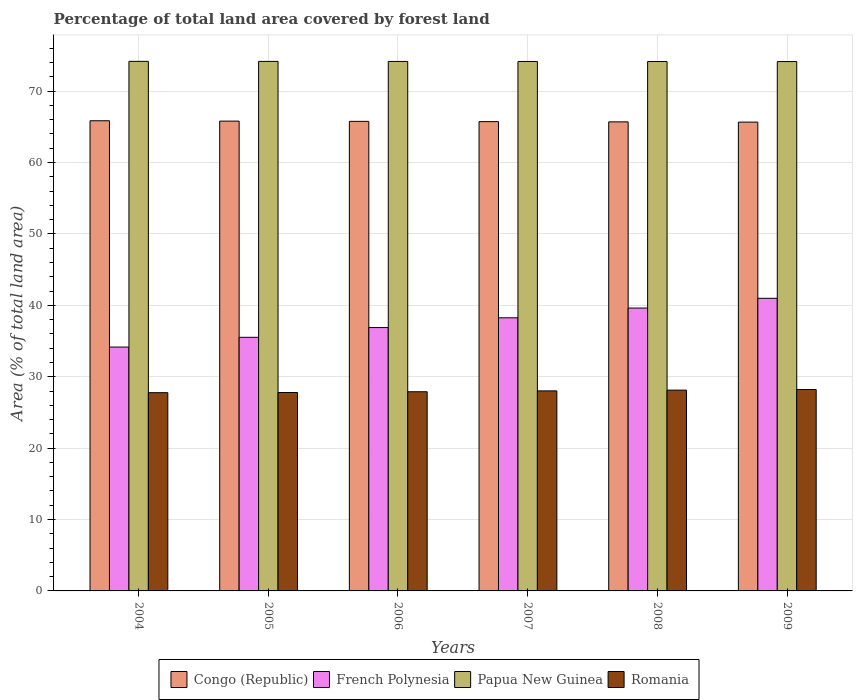How many groups of bars are there?
Make the answer very short. 6. Are the number of bars on each tick of the X-axis equal?
Ensure brevity in your answer.  Yes. How many bars are there on the 4th tick from the left?
Provide a short and direct response. 4. What is the label of the 5th group of bars from the left?
Ensure brevity in your answer.  2008. What is the percentage of forest land in Congo (Republic) in 2005?
Offer a very short reply. 65.8. Across all years, what is the maximum percentage of forest land in Papua New Guinea?
Offer a terse response. 74.17. Across all years, what is the minimum percentage of forest land in Congo (Republic)?
Provide a succinct answer. 65.66. In which year was the percentage of forest land in French Polynesia maximum?
Provide a short and direct response. 2009. What is the total percentage of forest land in Congo (Republic) in the graph?
Offer a very short reply. 394.5. What is the difference between the percentage of forest land in Papua New Guinea in 2005 and that in 2008?
Provide a succinct answer. 0.02. What is the difference between the percentage of forest land in Papua New Guinea in 2008 and the percentage of forest land in Romania in 2005?
Keep it short and to the point. 46.36. What is the average percentage of forest land in Papua New Guinea per year?
Offer a terse response. 74.16. In the year 2007, what is the difference between the percentage of forest land in French Polynesia and percentage of forest land in Congo (Republic)?
Provide a short and direct response. -27.48. In how many years, is the percentage of forest land in Romania greater than 34 %?
Provide a short and direct response. 0. What is the ratio of the percentage of forest land in French Polynesia in 2004 to that in 2008?
Offer a terse response. 0.86. Is the percentage of forest land in Romania in 2004 less than that in 2006?
Offer a very short reply. Yes. Is the difference between the percentage of forest land in French Polynesia in 2004 and 2005 greater than the difference between the percentage of forest land in Congo (Republic) in 2004 and 2005?
Ensure brevity in your answer.  No. What is the difference between the highest and the second highest percentage of forest land in French Polynesia?
Your answer should be compact. 1.37. What is the difference between the highest and the lowest percentage of forest land in Papua New Guinea?
Your answer should be very brief. 0.03. What does the 4th bar from the left in 2004 represents?
Offer a very short reply. Romania. What does the 4th bar from the right in 2004 represents?
Offer a very short reply. Congo (Republic). How many years are there in the graph?
Provide a succinct answer. 6. What is the difference between two consecutive major ticks on the Y-axis?
Your response must be concise. 10. Does the graph contain grids?
Keep it short and to the point. Yes. What is the title of the graph?
Your answer should be compact. Percentage of total land area covered by forest land. Does "Armenia" appear as one of the legend labels in the graph?
Make the answer very short. No. What is the label or title of the X-axis?
Give a very brief answer. Years. What is the label or title of the Y-axis?
Make the answer very short. Area (% of total land area). What is the Area (% of total land area) in Congo (Republic) in 2004?
Ensure brevity in your answer.  65.85. What is the Area (% of total land area) in French Polynesia in 2004?
Your answer should be compact. 34.15. What is the Area (% of total land area) in Papua New Guinea in 2004?
Your response must be concise. 74.17. What is the Area (% of total land area) of Romania in 2004?
Offer a terse response. 27.77. What is the Area (% of total land area) of Congo (Republic) in 2005?
Your answer should be very brief. 65.8. What is the Area (% of total land area) in French Polynesia in 2005?
Provide a short and direct response. 35.52. What is the Area (% of total land area) of Papua New Guinea in 2005?
Your answer should be compact. 74.16. What is the Area (% of total land area) of Romania in 2005?
Make the answer very short. 27.79. What is the Area (% of total land area) of Congo (Republic) in 2006?
Give a very brief answer. 65.77. What is the Area (% of total land area) of French Polynesia in 2006?
Offer a very short reply. 36.89. What is the Area (% of total land area) in Papua New Guinea in 2006?
Your answer should be very brief. 74.16. What is the Area (% of total land area) in Romania in 2006?
Your answer should be very brief. 27.9. What is the Area (% of total land area) in Congo (Republic) in 2007?
Ensure brevity in your answer.  65.73. What is the Area (% of total land area) of French Polynesia in 2007?
Provide a short and direct response. 38.25. What is the Area (% of total land area) of Papua New Guinea in 2007?
Offer a very short reply. 74.15. What is the Area (% of total land area) of Romania in 2007?
Your response must be concise. 28.02. What is the Area (% of total land area) of Congo (Republic) in 2008?
Your response must be concise. 65.7. What is the Area (% of total land area) of French Polynesia in 2008?
Your answer should be compact. 39.62. What is the Area (% of total land area) of Papua New Guinea in 2008?
Give a very brief answer. 74.15. What is the Area (% of total land area) of Romania in 2008?
Make the answer very short. 28.12. What is the Area (% of total land area) of Congo (Republic) in 2009?
Give a very brief answer. 65.66. What is the Area (% of total land area) in French Polynesia in 2009?
Provide a short and direct response. 40.98. What is the Area (% of total land area) of Papua New Guinea in 2009?
Provide a succinct answer. 74.14. What is the Area (% of total land area) in Romania in 2009?
Offer a terse response. 28.21. Across all years, what is the maximum Area (% of total land area) of Congo (Republic)?
Offer a very short reply. 65.85. Across all years, what is the maximum Area (% of total land area) of French Polynesia?
Ensure brevity in your answer.  40.98. Across all years, what is the maximum Area (% of total land area) of Papua New Guinea?
Your answer should be compact. 74.17. Across all years, what is the maximum Area (% of total land area) of Romania?
Provide a short and direct response. 28.21. Across all years, what is the minimum Area (% of total land area) of Congo (Republic)?
Offer a very short reply. 65.66. Across all years, what is the minimum Area (% of total land area) of French Polynesia?
Offer a terse response. 34.15. Across all years, what is the minimum Area (% of total land area) of Papua New Guinea?
Your answer should be very brief. 74.14. Across all years, what is the minimum Area (% of total land area) in Romania?
Your answer should be compact. 27.77. What is the total Area (% of total land area) of Congo (Republic) in the graph?
Provide a succinct answer. 394.5. What is the total Area (% of total land area) of French Polynesia in the graph?
Offer a very short reply. 225.41. What is the total Area (% of total land area) in Papua New Guinea in the graph?
Make the answer very short. 444.93. What is the total Area (% of total land area) of Romania in the graph?
Provide a succinct answer. 167.8. What is the difference between the Area (% of total land area) of Congo (Republic) in 2004 and that in 2005?
Your answer should be very brief. 0.05. What is the difference between the Area (% of total land area) of French Polynesia in 2004 and that in 2005?
Your answer should be very brief. -1.37. What is the difference between the Area (% of total land area) in Papua New Guinea in 2004 and that in 2005?
Your answer should be very brief. 0.01. What is the difference between the Area (% of total land area) in Romania in 2004 and that in 2005?
Your answer should be very brief. -0.02. What is the difference between the Area (% of total land area) in Congo (Republic) in 2004 and that in 2006?
Your answer should be very brief. 0.08. What is the difference between the Area (% of total land area) in French Polynesia in 2004 and that in 2006?
Your response must be concise. -2.73. What is the difference between the Area (% of total land area) in Papua New Guinea in 2004 and that in 2006?
Ensure brevity in your answer.  0.01. What is the difference between the Area (% of total land area) of Romania in 2004 and that in 2006?
Make the answer very short. -0.13. What is the difference between the Area (% of total land area) of Congo (Republic) in 2004 and that in 2007?
Your answer should be very brief. 0.12. What is the difference between the Area (% of total land area) of French Polynesia in 2004 and that in 2007?
Make the answer very short. -4.1. What is the difference between the Area (% of total land area) of Papua New Guinea in 2004 and that in 2007?
Offer a very short reply. 0.02. What is the difference between the Area (% of total land area) of Romania in 2004 and that in 2007?
Provide a short and direct response. -0.25. What is the difference between the Area (% of total land area) of Congo (Republic) in 2004 and that in 2008?
Give a very brief answer. 0.16. What is the difference between the Area (% of total land area) of French Polynesia in 2004 and that in 2008?
Offer a very short reply. -5.46. What is the difference between the Area (% of total land area) in Papua New Guinea in 2004 and that in 2008?
Make the answer very short. 0.02. What is the difference between the Area (% of total land area) of Romania in 2004 and that in 2008?
Offer a terse response. -0.36. What is the difference between the Area (% of total land area) in Congo (Republic) in 2004 and that in 2009?
Provide a succinct answer. 0.19. What is the difference between the Area (% of total land area) in French Polynesia in 2004 and that in 2009?
Offer a terse response. -6.83. What is the difference between the Area (% of total land area) of Papua New Guinea in 2004 and that in 2009?
Make the answer very short. 0.03. What is the difference between the Area (% of total land area) of Romania in 2004 and that in 2009?
Your response must be concise. -0.45. What is the difference between the Area (% of total land area) in Congo (Republic) in 2005 and that in 2006?
Your answer should be compact. 0.04. What is the difference between the Area (% of total land area) in French Polynesia in 2005 and that in 2006?
Your answer should be compact. -1.37. What is the difference between the Area (% of total land area) of Papua New Guinea in 2005 and that in 2006?
Offer a terse response. 0.01. What is the difference between the Area (% of total land area) of Romania in 2005 and that in 2006?
Offer a terse response. -0.11. What is the difference between the Area (% of total land area) in Congo (Republic) in 2005 and that in 2007?
Your answer should be compact. 0.07. What is the difference between the Area (% of total land area) of French Polynesia in 2005 and that in 2007?
Provide a short and direct response. -2.73. What is the difference between the Area (% of total land area) in Papua New Guinea in 2005 and that in 2007?
Keep it short and to the point. 0.01. What is the difference between the Area (% of total land area) of Romania in 2005 and that in 2007?
Give a very brief answer. -0.23. What is the difference between the Area (% of total land area) in Congo (Republic) in 2005 and that in 2008?
Provide a short and direct response. 0.11. What is the difference between the Area (% of total land area) of French Polynesia in 2005 and that in 2008?
Keep it short and to the point. -4.1. What is the difference between the Area (% of total land area) in Papua New Guinea in 2005 and that in 2008?
Give a very brief answer. 0.02. What is the difference between the Area (% of total land area) in Congo (Republic) in 2005 and that in 2009?
Offer a very short reply. 0.14. What is the difference between the Area (% of total land area) in French Polynesia in 2005 and that in 2009?
Make the answer very short. -5.46. What is the difference between the Area (% of total land area) in Papua New Guinea in 2005 and that in 2009?
Provide a short and direct response. 0.02. What is the difference between the Area (% of total land area) of Romania in 2005 and that in 2009?
Provide a short and direct response. -0.42. What is the difference between the Area (% of total land area) in Congo (Republic) in 2006 and that in 2007?
Your answer should be compact. 0.04. What is the difference between the Area (% of total land area) in French Polynesia in 2006 and that in 2007?
Make the answer very short. -1.37. What is the difference between the Area (% of total land area) in Papua New Guinea in 2006 and that in 2007?
Provide a succinct answer. 0.01. What is the difference between the Area (% of total land area) of Romania in 2006 and that in 2007?
Your response must be concise. -0.12. What is the difference between the Area (% of total land area) in Congo (Republic) in 2006 and that in 2008?
Ensure brevity in your answer.  0.07. What is the difference between the Area (% of total land area) in French Polynesia in 2006 and that in 2008?
Keep it short and to the point. -2.73. What is the difference between the Area (% of total land area) in Papua New Guinea in 2006 and that in 2008?
Provide a short and direct response. 0.01. What is the difference between the Area (% of total land area) in Romania in 2006 and that in 2008?
Offer a terse response. -0.23. What is the difference between the Area (% of total land area) of Congo (Republic) in 2006 and that in 2009?
Your response must be concise. 0.11. What is the difference between the Area (% of total land area) of French Polynesia in 2006 and that in 2009?
Offer a terse response. -4.1. What is the difference between the Area (% of total land area) of Papua New Guinea in 2006 and that in 2009?
Your answer should be compact. 0.02. What is the difference between the Area (% of total land area) in Romania in 2006 and that in 2009?
Your response must be concise. -0.31. What is the difference between the Area (% of total land area) in Congo (Republic) in 2007 and that in 2008?
Give a very brief answer. 0.04. What is the difference between the Area (% of total land area) in French Polynesia in 2007 and that in 2008?
Provide a succinct answer. -1.37. What is the difference between the Area (% of total land area) in Papua New Guinea in 2007 and that in 2008?
Offer a very short reply. 0.01. What is the difference between the Area (% of total land area) in Romania in 2007 and that in 2008?
Make the answer very short. -0.11. What is the difference between the Area (% of total land area) of Congo (Republic) in 2007 and that in 2009?
Your response must be concise. 0.07. What is the difference between the Area (% of total land area) in French Polynesia in 2007 and that in 2009?
Your response must be concise. -2.73. What is the difference between the Area (% of total land area) of Papua New Guinea in 2007 and that in 2009?
Your response must be concise. 0.01. What is the difference between the Area (% of total land area) of Romania in 2007 and that in 2009?
Your answer should be very brief. -0.19. What is the difference between the Area (% of total land area) in Congo (Republic) in 2008 and that in 2009?
Offer a terse response. 0.04. What is the difference between the Area (% of total land area) of French Polynesia in 2008 and that in 2009?
Offer a terse response. -1.37. What is the difference between the Area (% of total land area) of Papua New Guinea in 2008 and that in 2009?
Your answer should be very brief. 0.01. What is the difference between the Area (% of total land area) in Romania in 2008 and that in 2009?
Make the answer very short. -0.09. What is the difference between the Area (% of total land area) of Congo (Republic) in 2004 and the Area (% of total land area) of French Polynesia in 2005?
Provide a succinct answer. 30.33. What is the difference between the Area (% of total land area) in Congo (Republic) in 2004 and the Area (% of total land area) in Papua New Guinea in 2005?
Give a very brief answer. -8.31. What is the difference between the Area (% of total land area) in Congo (Republic) in 2004 and the Area (% of total land area) in Romania in 2005?
Your answer should be compact. 38.06. What is the difference between the Area (% of total land area) of French Polynesia in 2004 and the Area (% of total land area) of Papua New Guinea in 2005?
Your answer should be very brief. -40.01. What is the difference between the Area (% of total land area) in French Polynesia in 2004 and the Area (% of total land area) in Romania in 2005?
Provide a short and direct response. 6.36. What is the difference between the Area (% of total land area) in Papua New Guinea in 2004 and the Area (% of total land area) in Romania in 2005?
Make the answer very short. 46.38. What is the difference between the Area (% of total land area) of Congo (Republic) in 2004 and the Area (% of total land area) of French Polynesia in 2006?
Give a very brief answer. 28.97. What is the difference between the Area (% of total land area) of Congo (Republic) in 2004 and the Area (% of total land area) of Papua New Guinea in 2006?
Make the answer very short. -8.31. What is the difference between the Area (% of total land area) of Congo (Republic) in 2004 and the Area (% of total land area) of Romania in 2006?
Your response must be concise. 37.95. What is the difference between the Area (% of total land area) in French Polynesia in 2004 and the Area (% of total land area) in Papua New Guinea in 2006?
Your answer should be very brief. -40.01. What is the difference between the Area (% of total land area) in French Polynesia in 2004 and the Area (% of total land area) in Romania in 2006?
Your answer should be very brief. 6.26. What is the difference between the Area (% of total land area) of Papua New Guinea in 2004 and the Area (% of total land area) of Romania in 2006?
Give a very brief answer. 46.27. What is the difference between the Area (% of total land area) of Congo (Republic) in 2004 and the Area (% of total land area) of French Polynesia in 2007?
Your answer should be very brief. 27.6. What is the difference between the Area (% of total land area) in Congo (Republic) in 2004 and the Area (% of total land area) in Papua New Guinea in 2007?
Offer a very short reply. -8.3. What is the difference between the Area (% of total land area) in Congo (Republic) in 2004 and the Area (% of total land area) in Romania in 2007?
Keep it short and to the point. 37.83. What is the difference between the Area (% of total land area) of French Polynesia in 2004 and the Area (% of total land area) of Papua New Guinea in 2007?
Your answer should be very brief. -40. What is the difference between the Area (% of total land area) in French Polynesia in 2004 and the Area (% of total land area) in Romania in 2007?
Ensure brevity in your answer.  6.14. What is the difference between the Area (% of total land area) of Papua New Guinea in 2004 and the Area (% of total land area) of Romania in 2007?
Your answer should be very brief. 46.15. What is the difference between the Area (% of total land area) of Congo (Republic) in 2004 and the Area (% of total land area) of French Polynesia in 2008?
Provide a succinct answer. 26.23. What is the difference between the Area (% of total land area) in Congo (Republic) in 2004 and the Area (% of total land area) in Papua New Guinea in 2008?
Ensure brevity in your answer.  -8.3. What is the difference between the Area (% of total land area) of Congo (Republic) in 2004 and the Area (% of total land area) of Romania in 2008?
Keep it short and to the point. 37.73. What is the difference between the Area (% of total land area) of French Polynesia in 2004 and the Area (% of total land area) of Papua New Guinea in 2008?
Your answer should be compact. -39.99. What is the difference between the Area (% of total land area) of French Polynesia in 2004 and the Area (% of total land area) of Romania in 2008?
Your answer should be compact. 6.03. What is the difference between the Area (% of total land area) of Papua New Guinea in 2004 and the Area (% of total land area) of Romania in 2008?
Make the answer very short. 46.05. What is the difference between the Area (% of total land area) in Congo (Republic) in 2004 and the Area (% of total land area) in French Polynesia in 2009?
Ensure brevity in your answer.  24.87. What is the difference between the Area (% of total land area) in Congo (Republic) in 2004 and the Area (% of total land area) in Papua New Guinea in 2009?
Give a very brief answer. -8.29. What is the difference between the Area (% of total land area) in Congo (Republic) in 2004 and the Area (% of total land area) in Romania in 2009?
Provide a succinct answer. 37.64. What is the difference between the Area (% of total land area) in French Polynesia in 2004 and the Area (% of total land area) in Papua New Guinea in 2009?
Offer a very short reply. -39.99. What is the difference between the Area (% of total land area) in French Polynesia in 2004 and the Area (% of total land area) in Romania in 2009?
Your answer should be very brief. 5.94. What is the difference between the Area (% of total land area) in Papua New Guinea in 2004 and the Area (% of total land area) in Romania in 2009?
Provide a short and direct response. 45.96. What is the difference between the Area (% of total land area) of Congo (Republic) in 2005 and the Area (% of total land area) of French Polynesia in 2006?
Provide a succinct answer. 28.92. What is the difference between the Area (% of total land area) of Congo (Republic) in 2005 and the Area (% of total land area) of Papua New Guinea in 2006?
Ensure brevity in your answer.  -8.36. What is the difference between the Area (% of total land area) in Congo (Republic) in 2005 and the Area (% of total land area) in Romania in 2006?
Offer a very short reply. 37.9. What is the difference between the Area (% of total land area) of French Polynesia in 2005 and the Area (% of total land area) of Papua New Guinea in 2006?
Your answer should be very brief. -38.64. What is the difference between the Area (% of total land area) in French Polynesia in 2005 and the Area (% of total land area) in Romania in 2006?
Your answer should be compact. 7.62. What is the difference between the Area (% of total land area) in Papua New Guinea in 2005 and the Area (% of total land area) in Romania in 2006?
Give a very brief answer. 46.27. What is the difference between the Area (% of total land area) of Congo (Republic) in 2005 and the Area (% of total land area) of French Polynesia in 2007?
Your response must be concise. 27.55. What is the difference between the Area (% of total land area) of Congo (Republic) in 2005 and the Area (% of total land area) of Papua New Guinea in 2007?
Your answer should be very brief. -8.35. What is the difference between the Area (% of total land area) of Congo (Republic) in 2005 and the Area (% of total land area) of Romania in 2007?
Provide a succinct answer. 37.78. What is the difference between the Area (% of total land area) of French Polynesia in 2005 and the Area (% of total land area) of Papua New Guinea in 2007?
Your answer should be very brief. -38.63. What is the difference between the Area (% of total land area) of French Polynesia in 2005 and the Area (% of total land area) of Romania in 2007?
Provide a succinct answer. 7.5. What is the difference between the Area (% of total land area) of Papua New Guinea in 2005 and the Area (% of total land area) of Romania in 2007?
Make the answer very short. 46.15. What is the difference between the Area (% of total land area) in Congo (Republic) in 2005 and the Area (% of total land area) in French Polynesia in 2008?
Offer a very short reply. 26.18. What is the difference between the Area (% of total land area) in Congo (Republic) in 2005 and the Area (% of total land area) in Papua New Guinea in 2008?
Make the answer very short. -8.35. What is the difference between the Area (% of total land area) of Congo (Republic) in 2005 and the Area (% of total land area) of Romania in 2008?
Provide a succinct answer. 37.68. What is the difference between the Area (% of total land area) in French Polynesia in 2005 and the Area (% of total land area) in Papua New Guinea in 2008?
Your answer should be compact. -38.63. What is the difference between the Area (% of total land area) in French Polynesia in 2005 and the Area (% of total land area) in Romania in 2008?
Make the answer very short. 7.4. What is the difference between the Area (% of total land area) of Papua New Guinea in 2005 and the Area (% of total land area) of Romania in 2008?
Keep it short and to the point. 46.04. What is the difference between the Area (% of total land area) of Congo (Republic) in 2005 and the Area (% of total land area) of French Polynesia in 2009?
Provide a succinct answer. 24.82. What is the difference between the Area (% of total land area) of Congo (Republic) in 2005 and the Area (% of total land area) of Papua New Guinea in 2009?
Provide a succinct answer. -8.34. What is the difference between the Area (% of total land area) of Congo (Republic) in 2005 and the Area (% of total land area) of Romania in 2009?
Offer a terse response. 37.59. What is the difference between the Area (% of total land area) of French Polynesia in 2005 and the Area (% of total land area) of Papua New Guinea in 2009?
Your answer should be very brief. -38.62. What is the difference between the Area (% of total land area) of French Polynesia in 2005 and the Area (% of total land area) of Romania in 2009?
Your answer should be very brief. 7.31. What is the difference between the Area (% of total land area) in Papua New Guinea in 2005 and the Area (% of total land area) in Romania in 2009?
Offer a terse response. 45.95. What is the difference between the Area (% of total land area) in Congo (Republic) in 2006 and the Area (% of total land area) in French Polynesia in 2007?
Provide a short and direct response. 27.51. What is the difference between the Area (% of total land area) of Congo (Republic) in 2006 and the Area (% of total land area) of Papua New Guinea in 2007?
Your response must be concise. -8.39. What is the difference between the Area (% of total land area) in Congo (Republic) in 2006 and the Area (% of total land area) in Romania in 2007?
Provide a short and direct response. 37.75. What is the difference between the Area (% of total land area) of French Polynesia in 2006 and the Area (% of total land area) of Papua New Guinea in 2007?
Offer a very short reply. -37.27. What is the difference between the Area (% of total land area) in French Polynesia in 2006 and the Area (% of total land area) in Romania in 2007?
Your answer should be compact. 8.87. What is the difference between the Area (% of total land area) in Papua New Guinea in 2006 and the Area (% of total land area) in Romania in 2007?
Offer a terse response. 46.14. What is the difference between the Area (% of total land area) of Congo (Republic) in 2006 and the Area (% of total land area) of French Polynesia in 2008?
Provide a succinct answer. 26.15. What is the difference between the Area (% of total land area) in Congo (Republic) in 2006 and the Area (% of total land area) in Papua New Guinea in 2008?
Your answer should be very brief. -8.38. What is the difference between the Area (% of total land area) in Congo (Republic) in 2006 and the Area (% of total land area) in Romania in 2008?
Make the answer very short. 37.64. What is the difference between the Area (% of total land area) of French Polynesia in 2006 and the Area (% of total land area) of Papua New Guinea in 2008?
Offer a terse response. -37.26. What is the difference between the Area (% of total land area) of French Polynesia in 2006 and the Area (% of total land area) of Romania in 2008?
Give a very brief answer. 8.76. What is the difference between the Area (% of total land area) in Papua New Guinea in 2006 and the Area (% of total land area) in Romania in 2008?
Keep it short and to the point. 46.04. What is the difference between the Area (% of total land area) in Congo (Republic) in 2006 and the Area (% of total land area) in French Polynesia in 2009?
Your answer should be compact. 24.78. What is the difference between the Area (% of total land area) in Congo (Republic) in 2006 and the Area (% of total land area) in Papua New Guinea in 2009?
Ensure brevity in your answer.  -8.38. What is the difference between the Area (% of total land area) in Congo (Republic) in 2006 and the Area (% of total land area) in Romania in 2009?
Your answer should be compact. 37.55. What is the difference between the Area (% of total land area) in French Polynesia in 2006 and the Area (% of total land area) in Papua New Guinea in 2009?
Your answer should be very brief. -37.26. What is the difference between the Area (% of total land area) in French Polynesia in 2006 and the Area (% of total land area) in Romania in 2009?
Your answer should be very brief. 8.67. What is the difference between the Area (% of total land area) of Papua New Guinea in 2006 and the Area (% of total land area) of Romania in 2009?
Provide a succinct answer. 45.95. What is the difference between the Area (% of total land area) in Congo (Republic) in 2007 and the Area (% of total land area) in French Polynesia in 2008?
Provide a short and direct response. 26.11. What is the difference between the Area (% of total land area) in Congo (Republic) in 2007 and the Area (% of total land area) in Papua New Guinea in 2008?
Keep it short and to the point. -8.42. What is the difference between the Area (% of total land area) of Congo (Republic) in 2007 and the Area (% of total land area) of Romania in 2008?
Your answer should be compact. 37.61. What is the difference between the Area (% of total land area) of French Polynesia in 2007 and the Area (% of total land area) of Papua New Guinea in 2008?
Keep it short and to the point. -35.9. What is the difference between the Area (% of total land area) in French Polynesia in 2007 and the Area (% of total land area) in Romania in 2008?
Make the answer very short. 10.13. What is the difference between the Area (% of total land area) of Papua New Guinea in 2007 and the Area (% of total land area) of Romania in 2008?
Offer a terse response. 46.03. What is the difference between the Area (% of total land area) of Congo (Republic) in 2007 and the Area (% of total land area) of French Polynesia in 2009?
Offer a very short reply. 24.75. What is the difference between the Area (% of total land area) in Congo (Republic) in 2007 and the Area (% of total land area) in Papua New Guinea in 2009?
Ensure brevity in your answer.  -8.41. What is the difference between the Area (% of total land area) of Congo (Republic) in 2007 and the Area (% of total land area) of Romania in 2009?
Your response must be concise. 37.52. What is the difference between the Area (% of total land area) of French Polynesia in 2007 and the Area (% of total land area) of Papua New Guinea in 2009?
Offer a very short reply. -35.89. What is the difference between the Area (% of total land area) of French Polynesia in 2007 and the Area (% of total land area) of Romania in 2009?
Provide a succinct answer. 10.04. What is the difference between the Area (% of total land area) of Papua New Guinea in 2007 and the Area (% of total land area) of Romania in 2009?
Your answer should be compact. 45.94. What is the difference between the Area (% of total land area) of Congo (Republic) in 2008 and the Area (% of total land area) of French Polynesia in 2009?
Your response must be concise. 24.71. What is the difference between the Area (% of total land area) in Congo (Republic) in 2008 and the Area (% of total land area) in Papua New Guinea in 2009?
Your answer should be very brief. -8.45. What is the difference between the Area (% of total land area) of Congo (Republic) in 2008 and the Area (% of total land area) of Romania in 2009?
Offer a very short reply. 37.48. What is the difference between the Area (% of total land area) of French Polynesia in 2008 and the Area (% of total land area) of Papua New Guinea in 2009?
Give a very brief answer. -34.52. What is the difference between the Area (% of total land area) of French Polynesia in 2008 and the Area (% of total land area) of Romania in 2009?
Offer a very short reply. 11.41. What is the difference between the Area (% of total land area) in Papua New Guinea in 2008 and the Area (% of total land area) in Romania in 2009?
Make the answer very short. 45.94. What is the average Area (% of total land area) in Congo (Republic) per year?
Your response must be concise. 65.75. What is the average Area (% of total land area) of French Polynesia per year?
Offer a terse response. 37.57. What is the average Area (% of total land area) of Papua New Guinea per year?
Keep it short and to the point. 74.16. What is the average Area (% of total land area) in Romania per year?
Your response must be concise. 27.97. In the year 2004, what is the difference between the Area (% of total land area) of Congo (Republic) and Area (% of total land area) of French Polynesia?
Make the answer very short. 31.7. In the year 2004, what is the difference between the Area (% of total land area) in Congo (Republic) and Area (% of total land area) in Papua New Guinea?
Make the answer very short. -8.32. In the year 2004, what is the difference between the Area (% of total land area) of Congo (Republic) and Area (% of total land area) of Romania?
Offer a very short reply. 38.09. In the year 2004, what is the difference between the Area (% of total land area) in French Polynesia and Area (% of total land area) in Papua New Guinea?
Give a very brief answer. -40.02. In the year 2004, what is the difference between the Area (% of total land area) of French Polynesia and Area (% of total land area) of Romania?
Give a very brief answer. 6.39. In the year 2004, what is the difference between the Area (% of total land area) of Papua New Guinea and Area (% of total land area) of Romania?
Give a very brief answer. 46.41. In the year 2005, what is the difference between the Area (% of total land area) of Congo (Republic) and Area (% of total land area) of French Polynesia?
Ensure brevity in your answer.  30.28. In the year 2005, what is the difference between the Area (% of total land area) of Congo (Republic) and Area (% of total land area) of Papua New Guinea?
Your answer should be compact. -8.36. In the year 2005, what is the difference between the Area (% of total land area) of Congo (Republic) and Area (% of total land area) of Romania?
Keep it short and to the point. 38.01. In the year 2005, what is the difference between the Area (% of total land area) of French Polynesia and Area (% of total land area) of Papua New Guinea?
Ensure brevity in your answer.  -38.65. In the year 2005, what is the difference between the Area (% of total land area) in French Polynesia and Area (% of total land area) in Romania?
Your response must be concise. 7.73. In the year 2005, what is the difference between the Area (% of total land area) in Papua New Guinea and Area (% of total land area) in Romania?
Your response must be concise. 46.37. In the year 2006, what is the difference between the Area (% of total land area) in Congo (Republic) and Area (% of total land area) in French Polynesia?
Offer a terse response. 28.88. In the year 2006, what is the difference between the Area (% of total land area) of Congo (Republic) and Area (% of total land area) of Papua New Guinea?
Your answer should be very brief. -8.39. In the year 2006, what is the difference between the Area (% of total land area) in Congo (Republic) and Area (% of total land area) in Romania?
Ensure brevity in your answer.  37.87. In the year 2006, what is the difference between the Area (% of total land area) of French Polynesia and Area (% of total land area) of Papua New Guinea?
Your answer should be very brief. -37.27. In the year 2006, what is the difference between the Area (% of total land area) in French Polynesia and Area (% of total land area) in Romania?
Offer a very short reply. 8.99. In the year 2006, what is the difference between the Area (% of total land area) of Papua New Guinea and Area (% of total land area) of Romania?
Provide a succinct answer. 46.26. In the year 2007, what is the difference between the Area (% of total land area) of Congo (Republic) and Area (% of total land area) of French Polynesia?
Provide a short and direct response. 27.48. In the year 2007, what is the difference between the Area (% of total land area) in Congo (Republic) and Area (% of total land area) in Papua New Guinea?
Your answer should be compact. -8.42. In the year 2007, what is the difference between the Area (% of total land area) of Congo (Republic) and Area (% of total land area) of Romania?
Your answer should be very brief. 37.71. In the year 2007, what is the difference between the Area (% of total land area) in French Polynesia and Area (% of total land area) in Papua New Guinea?
Your answer should be compact. -35.9. In the year 2007, what is the difference between the Area (% of total land area) of French Polynesia and Area (% of total land area) of Romania?
Offer a terse response. 10.24. In the year 2007, what is the difference between the Area (% of total land area) of Papua New Guinea and Area (% of total land area) of Romania?
Your response must be concise. 46.14. In the year 2008, what is the difference between the Area (% of total land area) in Congo (Republic) and Area (% of total land area) in French Polynesia?
Ensure brevity in your answer.  26.08. In the year 2008, what is the difference between the Area (% of total land area) in Congo (Republic) and Area (% of total land area) in Papua New Guinea?
Offer a terse response. -8.45. In the year 2008, what is the difference between the Area (% of total land area) in Congo (Republic) and Area (% of total land area) in Romania?
Offer a very short reply. 37.57. In the year 2008, what is the difference between the Area (% of total land area) of French Polynesia and Area (% of total land area) of Papua New Guinea?
Offer a terse response. -34.53. In the year 2008, what is the difference between the Area (% of total land area) of French Polynesia and Area (% of total land area) of Romania?
Provide a short and direct response. 11.49. In the year 2008, what is the difference between the Area (% of total land area) in Papua New Guinea and Area (% of total land area) in Romania?
Give a very brief answer. 46.02. In the year 2009, what is the difference between the Area (% of total land area) in Congo (Republic) and Area (% of total land area) in French Polynesia?
Provide a short and direct response. 24.68. In the year 2009, what is the difference between the Area (% of total land area) of Congo (Republic) and Area (% of total land area) of Papua New Guinea?
Give a very brief answer. -8.48. In the year 2009, what is the difference between the Area (% of total land area) in Congo (Republic) and Area (% of total land area) in Romania?
Keep it short and to the point. 37.45. In the year 2009, what is the difference between the Area (% of total land area) of French Polynesia and Area (% of total land area) of Papua New Guinea?
Provide a succinct answer. -33.16. In the year 2009, what is the difference between the Area (% of total land area) of French Polynesia and Area (% of total land area) of Romania?
Your answer should be very brief. 12.77. In the year 2009, what is the difference between the Area (% of total land area) of Papua New Guinea and Area (% of total land area) of Romania?
Offer a terse response. 45.93. What is the ratio of the Area (% of total land area) of Congo (Republic) in 2004 to that in 2005?
Keep it short and to the point. 1. What is the ratio of the Area (% of total land area) of French Polynesia in 2004 to that in 2005?
Your response must be concise. 0.96. What is the ratio of the Area (% of total land area) in Romania in 2004 to that in 2005?
Keep it short and to the point. 1. What is the ratio of the Area (% of total land area) in Congo (Republic) in 2004 to that in 2006?
Your response must be concise. 1. What is the ratio of the Area (% of total land area) in French Polynesia in 2004 to that in 2006?
Give a very brief answer. 0.93. What is the ratio of the Area (% of total land area) of Papua New Guinea in 2004 to that in 2006?
Provide a short and direct response. 1. What is the ratio of the Area (% of total land area) in Romania in 2004 to that in 2006?
Your answer should be compact. 1. What is the ratio of the Area (% of total land area) in French Polynesia in 2004 to that in 2007?
Provide a succinct answer. 0.89. What is the ratio of the Area (% of total land area) of Papua New Guinea in 2004 to that in 2007?
Provide a succinct answer. 1. What is the ratio of the Area (% of total land area) of French Polynesia in 2004 to that in 2008?
Your answer should be compact. 0.86. What is the ratio of the Area (% of total land area) of Romania in 2004 to that in 2008?
Provide a succinct answer. 0.99. What is the ratio of the Area (% of total land area) of French Polynesia in 2004 to that in 2009?
Keep it short and to the point. 0.83. What is the ratio of the Area (% of total land area) in Papua New Guinea in 2004 to that in 2009?
Keep it short and to the point. 1. What is the ratio of the Area (% of total land area) in Romania in 2004 to that in 2009?
Give a very brief answer. 0.98. What is the ratio of the Area (% of total land area) in Congo (Republic) in 2005 to that in 2006?
Provide a succinct answer. 1. What is the ratio of the Area (% of total land area) in French Polynesia in 2005 to that in 2006?
Provide a short and direct response. 0.96. What is the ratio of the Area (% of total land area) in Papua New Guinea in 2005 to that in 2006?
Your answer should be compact. 1. What is the ratio of the Area (% of total land area) of French Polynesia in 2005 to that in 2007?
Make the answer very short. 0.93. What is the ratio of the Area (% of total land area) of Papua New Guinea in 2005 to that in 2007?
Offer a terse response. 1. What is the ratio of the Area (% of total land area) of Romania in 2005 to that in 2007?
Ensure brevity in your answer.  0.99. What is the ratio of the Area (% of total land area) in Congo (Republic) in 2005 to that in 2008?
Offer a very short reply. 1. What is the ratio of the Area (% of total land area) in French Polynesia in 2005 to that in 2008?
Give a very brief answer. 0.9. What is the ratio of the Area (% of total land area) of Papua New Guinea in 2005 to that in 2008?
Offer a very short reply. 1. What is the ratio of the Area (% of total land area) of Romania in 2005 to that in 2008?
Offer a very short reply. 0.99. What is the ratio of the Area (% of total land area) of French Polynesia in 2005 to that in 2009?
Give a very brief answer. 0.87. What is the ratio of the Area (% of total land area) in Romania in 2005 to that in 2009?
Keep it short and to the point. 0.99. What is the ratio of the Area (% of total land area) of Congo (Republic) in 2006 to that in 2008?
Make the answer very short. 1. What is the ratio of the Area (% of total land area) in Congo (Republic) in 2006 to that in 2009?
Make the answer very short. 1. What is the ratio of the Area (% of total land area) in Papua New Guinea in 2006 to that in 2009?
Make the answer very short. 1. What is the ratio of the Area (% of total land area) in Romania in 2006 to that in 2009?
Make the answer very short. 0.99. What is the ratio of the Area (% of total land area) in French Polynesia in 2007 to that in 2008?
Offer a terse response. 0.97. What is the ratio of the Area (% of total land area) in Papua New Guinea in 2007 to that in 2008?
Offer a terse response. 1. What is the ratio of the Area (% of total land area) of Congo (Republic) in 2007 to that in 2009?
Keep it short and to the point. 1. What is the ratio of the Area (% of total land area) of Romania in 2007 to that in 2009?
Offer a terse response. 0.99. What is the ratio of the Area (% of total land area) in Congo (Republic) in 2008 to that in 2009?
Provide a short and direct response. 1. What is the ratio of the Area (% of total land area) in French Polynesia in 2008 to that in 2009?
Your response must be concise. 0.97. What is the ratio of the Area (% of total land area) in Papua New Guinea in 2008 to that in 2009?
Provide a short and direct response. 1. What is the difference between the highest and the second highest Area (% of total land area) in Congo (Republic)?
Your response must be concise. 0.05. What is the difference between the highest and the second highest Area (% of total land area) of French Polynesia?
Keep it short and to the point. 1.37. What is the difference between the highest and the second highest Area (% of total land area) of Papua New Guinea?
Offer a terse response. 0.01. What is the difference between the highest and the second highest Area (% of total land area) in Romania?
Your answer should be very brief. 0.09. What is the difference between the highest and the lowest Area (% of total land area) in Congo (Republic)?
Offer a very short reply. 0.19. What is the difference between the highest and the lowest Area (% of total land area) of French Polynesia?
Keep it short and to the point. 6.83. What is the difference between the highest and the lowest Area (% of total land area) in Papua New Guinea?
Your response must be concise. 0.03. What is the difference between the highest and the lowest Area (% of total land area) of Romania?
Keep it short and to the point. 0.45. 